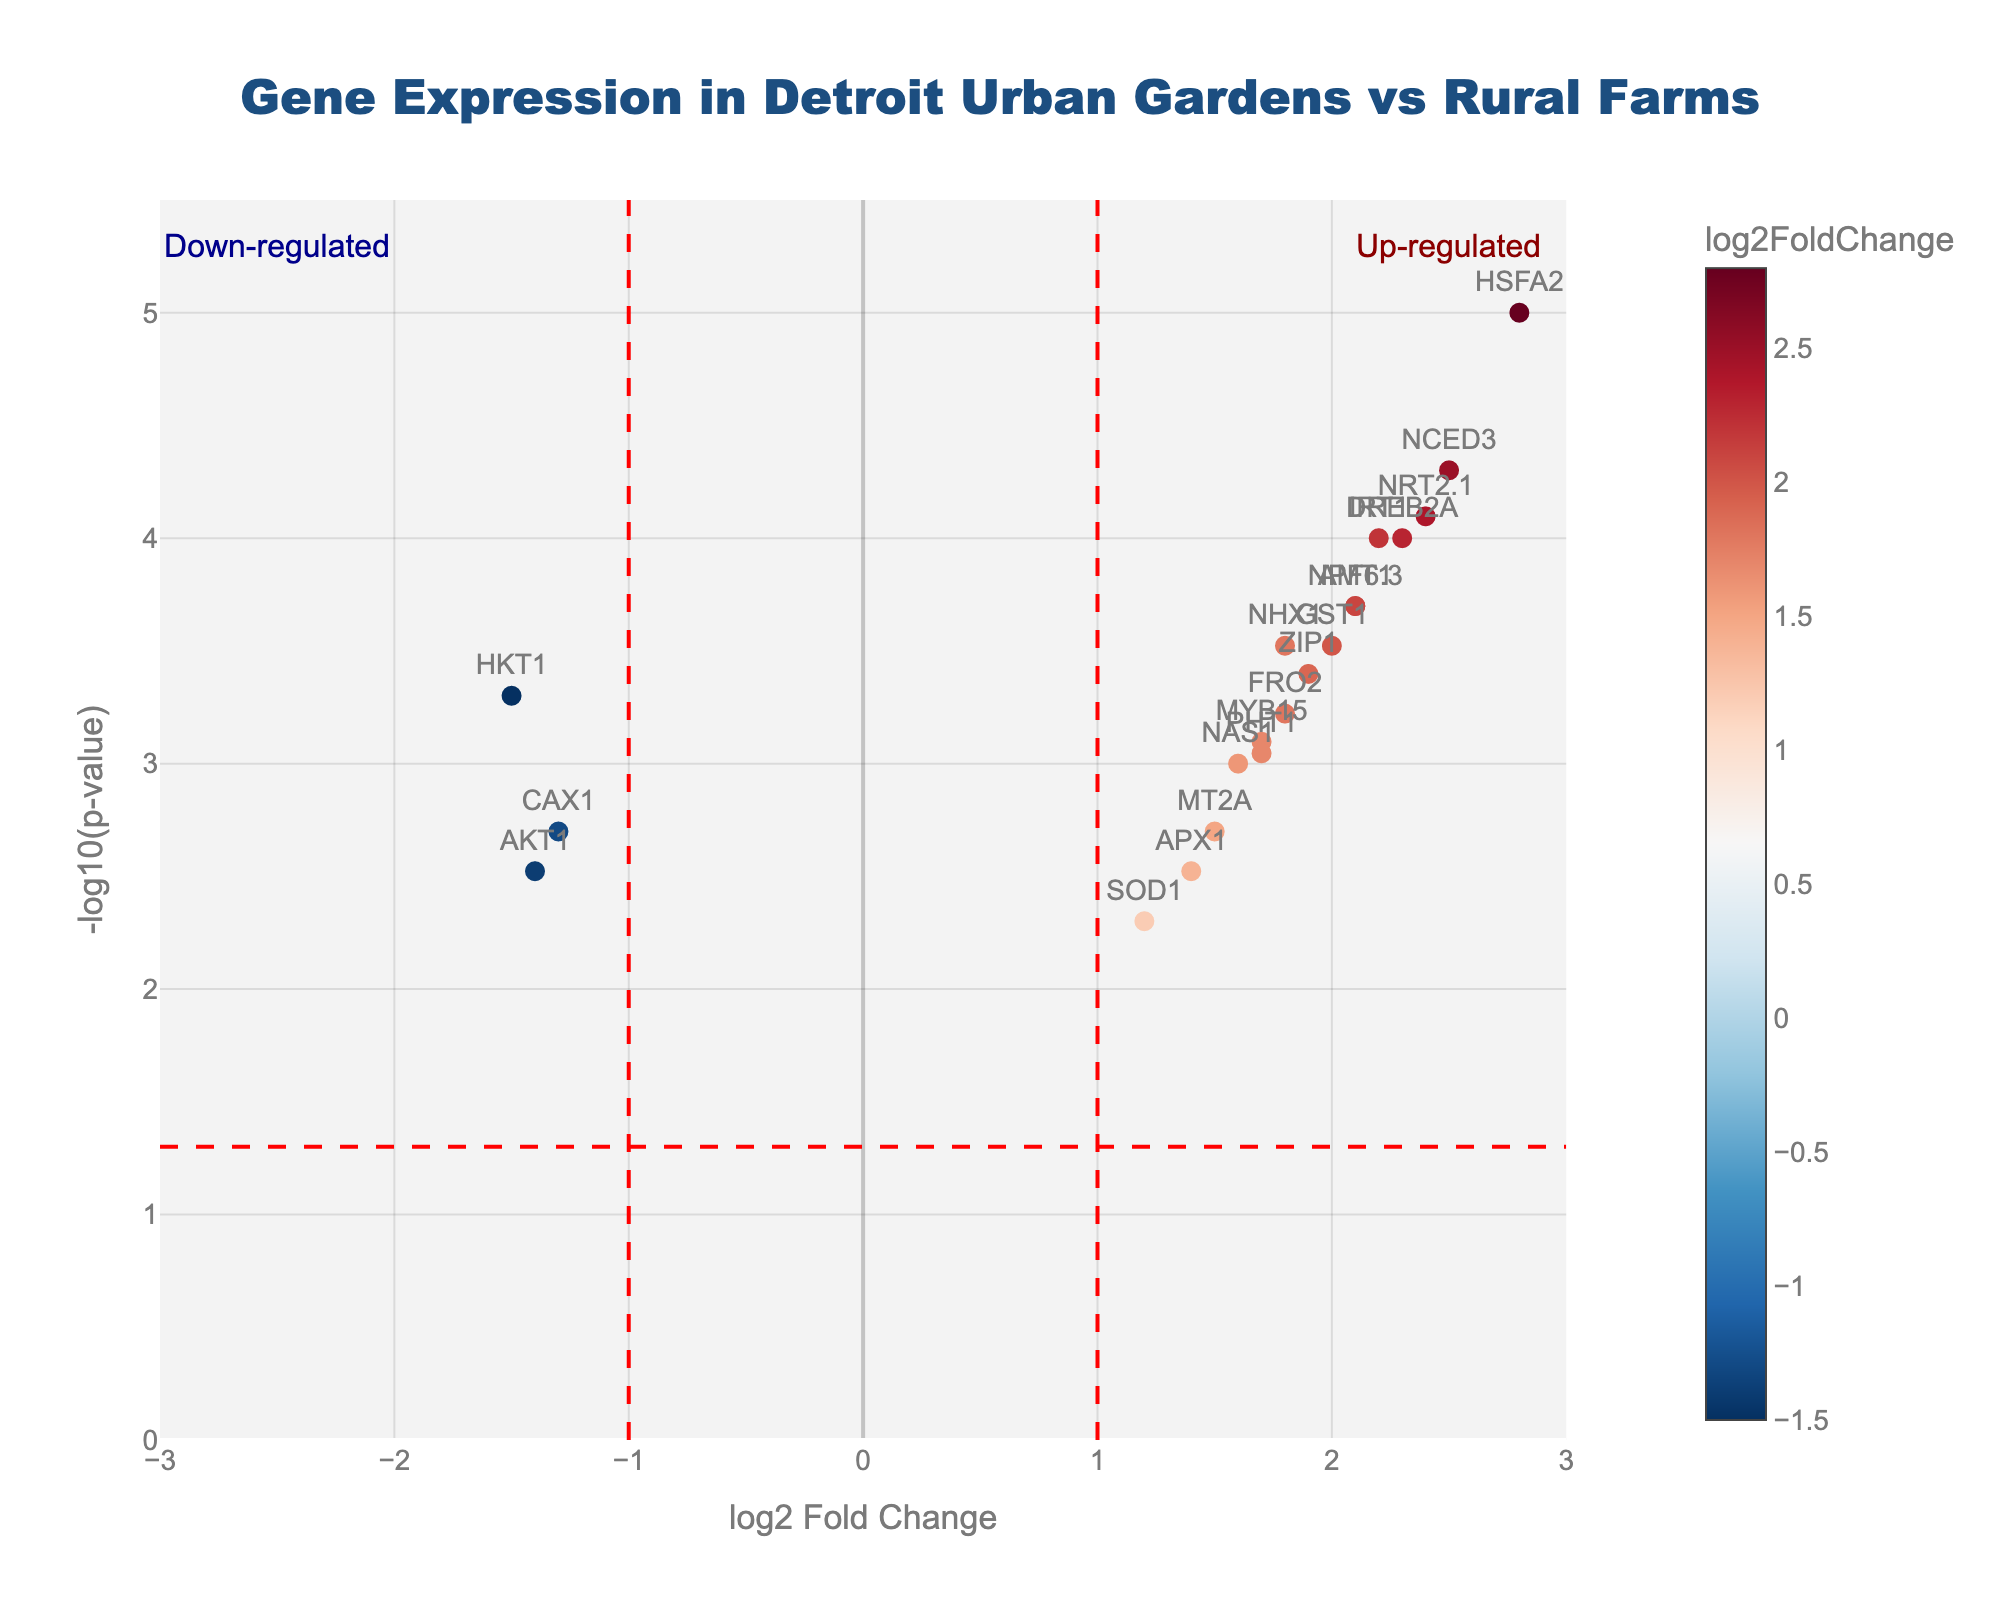What is the title of the plot? The title of the plot is displayed at the top center of the figure and provides a summary of the data presented.
Answer: Gene Expression in Detroit Urban Gardens vs Rural Farms Which gene has the highest -log10(p-value)? By looking at the y-axis value, which represents -log10(p-value), the gene with the highest point on the y-axis is identified.
Answer: HSFA2 How many genes appear up-regulated significantly in the plot? Up-regulated genes will have a positive log2FoldChange and a -log10(p-value) above the horizontal red dashed line (-log10(0.05)). Count the points on the right side of the origin and above the horizontal line.
Answer: 7 Which genes are down-regulated significantly? Down-regulated genes will have a negative log2FoldChange and a -log10(p-value) above the horizontal red dashed line (-log10(0.05)). Identify the points on the left side of the origin and above the horizontal line.
Answer: HKT1, CAX1, AKT1 What is the log2FoldChange value for the NHX1 gene? Look for the gene NHX1 on the plot. The x-axis value of its marker gives the log2FoldChange.
Answer: 1.8 Which genes show a log2FoldChange greater than 2? Identify the points to the right of the vertical red dashed line at log2FoldChange = 2.
Answer: DREB2A, NCED3, IRT1, NRT2.1, HSFA2 Compare the -log10(p-value) of genes DREB2A and NHX1. Which one is higher? Locate both genes on the plot and compare their positions on the y-axis. The higher value corresponds to the higher -log10(p-value).
Answer: DREB2A For the gene SOD1, is it significantly differentially expressed? Check the position of the gene SOD1 on the plot. It is significantly differentially expressed if it lies above the horizontal red dashed line at -log10(p-value) = 1.3.
Answer: No What is the p-value associated with the gene MYB15? The p-value can be inferred from the -log10(p-value). Use the transformation p-value = 10^(-log10(p-value)).
Answer: 0.0008 Which gene has the closest log2FoldChange to 0 but is still significantly differentially expressed? Identify the gene closest to the y-axis (log2FoldChange = 0) that lies above the horizontal red dashed line (-log10(p-value) = 1.3).
Answer: GST1 